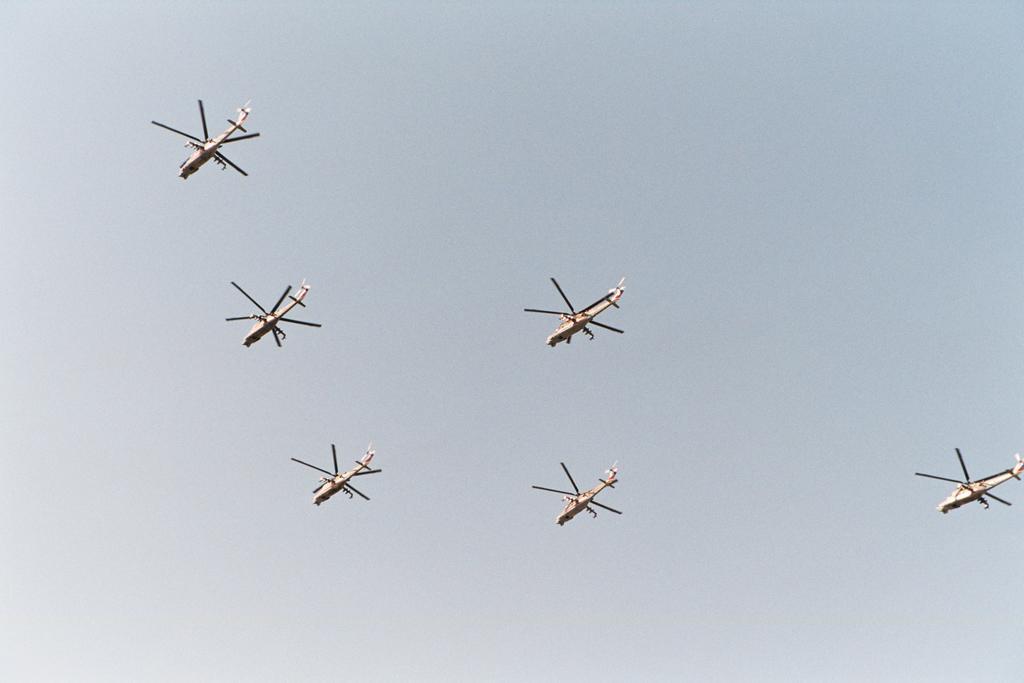In one or two sentences, can you explain what this image depicts? In this picture we can see six helicopters flying in the sky. 